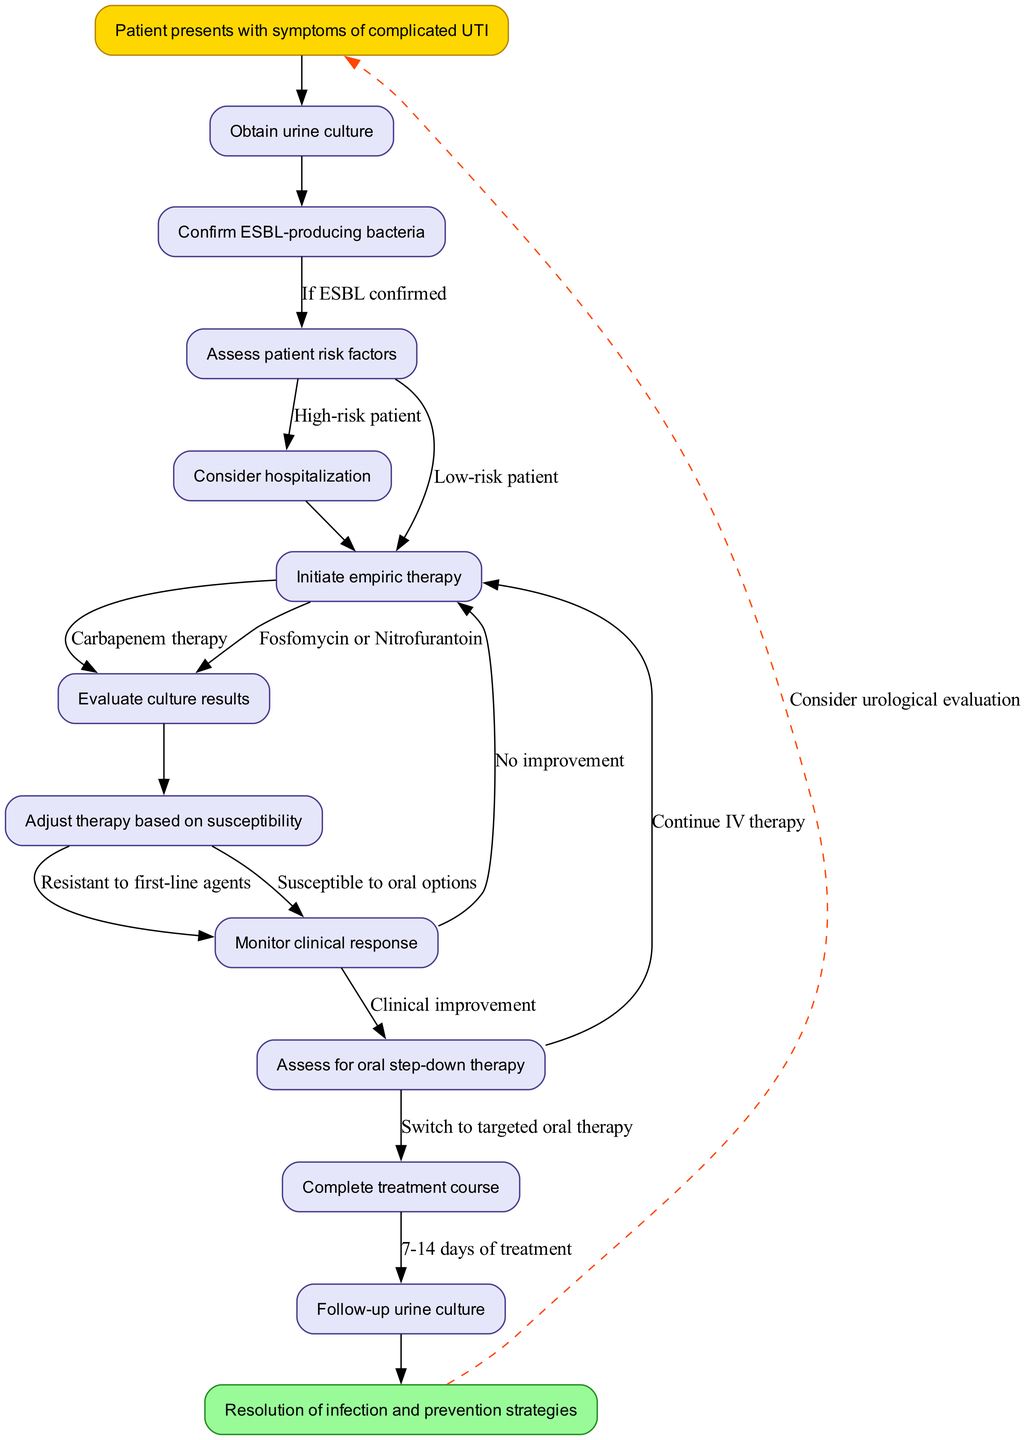What is the first node in the clinical pathway? The first node is labeled "Obtain urine culture", indicating the initial action taken when a patient presents with symptoms of a complicated UTI.
Answer: Obtain urine culture How many nodes are present in the diagram? By counting all the stated nodes, we find there are 11 nodes outlined in the clinical pathway, including both the starting and ending nodes.
Answer: 11 What is the last step in the pathway? The last step is "Resolution of infection and prevention strategies," serving as the endpoint of the clinical pathway after treatment is completed.
Answer: Resolution of infection and prevention strategies What therapy is initiated if the patient is at high risk? If the patient is determined to be at high risk, "Carbapenem therapy" is indicated as the appropriate treatment to address ESBL-producing bacteria.
Answer: Carbapenem therapy How long is the treatment course suggested in the pathway? The diagram specifies that the treatment course should be completed over a duration of "7-14 days of treatment," providing a clear timeframe for therapy.
Answer: 7-14 days of treatment What should be done if the patient shows no improvement? If there is "No improvement" in the patient's clinical response, the next step is to "Continue IV therapy" as indicated in the pathway for management of complicated UTIs.
Answer: Continue IV therapy What is evaluated after the urine culture results are obtained? After evaluating the culture results which confirm susceptibility, "Adjust therapy based on susceptibility" is the next action to personalize treatment for the patient.
Answer: Adjust therapy based on susceptibility What is the outcome if the patient is susceptible to oral options? If the patient is susceptible to oral options, the pathway instructs to "Switch to targeted oral therapy", transitioning from IV to oral medication when feasible.
Answer: Switch to targeted oral therapy 